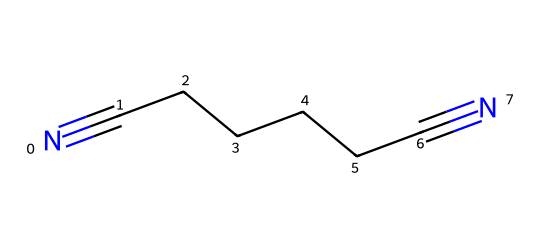What is the molecular formula of adiponitrile? The given SMILES representation indicates the presence of 6 carbon atoms (C) and 2 nitrogen atoms (N). Thus, the molecular formula can be derived from these counts.
Answer: C6H10N2 How many carbon atoms are present in adiponitrile? By analyzing the SMILES structure, we count the linear sequence of carbon atoms, which sums to 6.
Answer: 6 What type of functional groups are represented in adiponitrile? The chemical structure features nitrile functional groups (-C≡N), which are characteristic of nitriles. Therefore, the primary functional group present is nitrile.
Answer: nitrile How many triple bonds are present in adiponitrile? The structure shows two instances of a carbon-nitrogen triple bond, which indicates two triple bonds in total.
Answer: 2 What type of chemical reaction is adiponitrile primarily used for in nylon production? Adiponitrile is used in polymerization reactions, wherein it serves as a key intermediate in the synthesis of nylon.
Answer: polymerization What is the significance of the nitrogen atoms in adiponitrile? The two nitrogen atoms characterize the nitrile groups, which are pivotal in determining the properties and reactivity of the compound, especially in nylon synthesis.
Answer: reactivity 